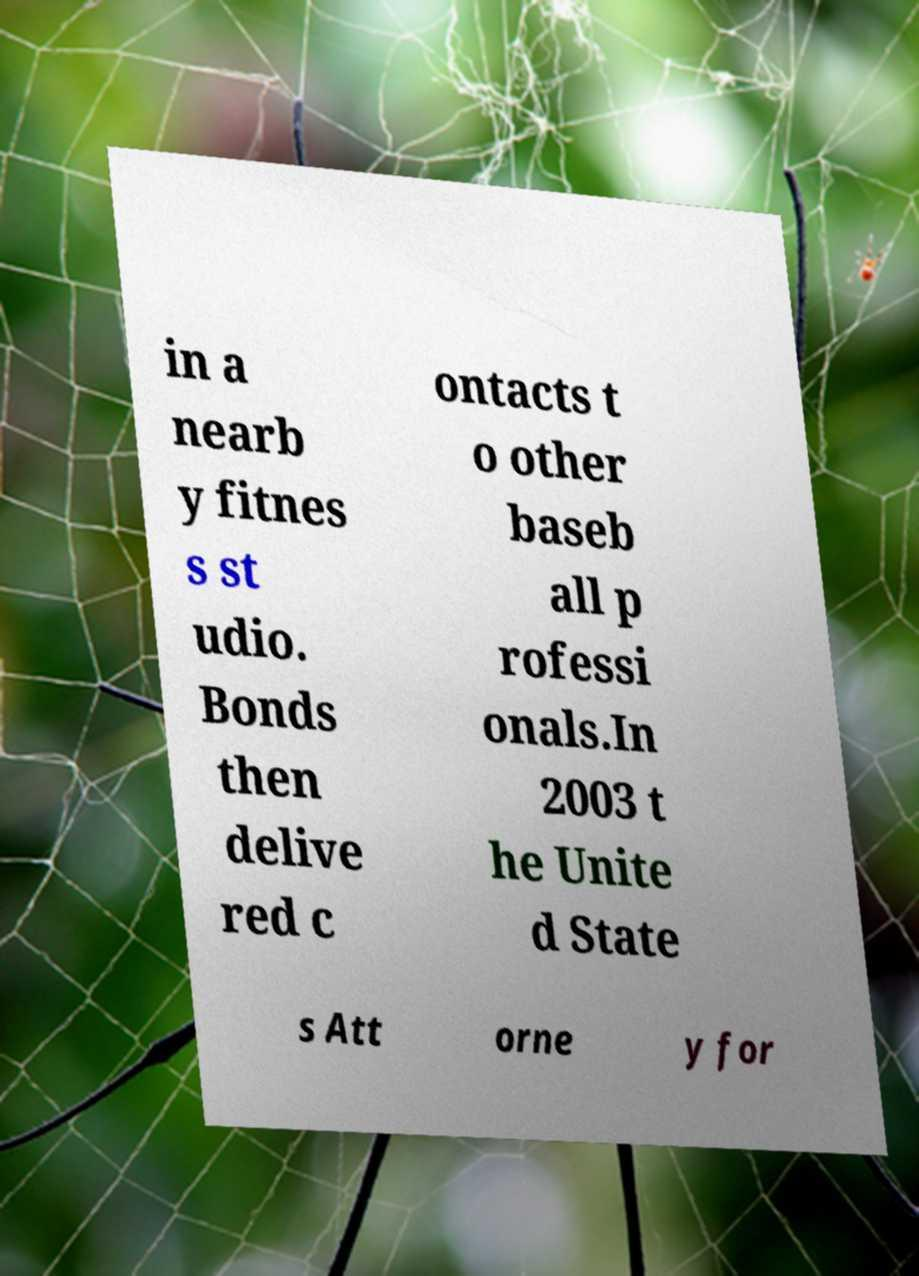I need the written content from this picture converted into text. Can you do that? in a nearb y fitnes s st udio. Bonds then delive red c ontacts t o other baseb all p rofessi onals.In 2003 t he Unite d State s Att orne y for 